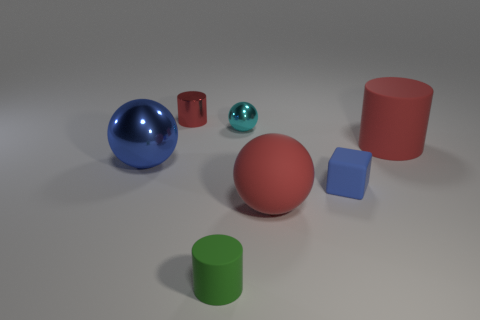Are there any metallic spheres of the same color as the rubber block?
Your answer should be very brief. Yes. What number of large objects are yellow metal spheres or green objects?
Give a very brief answer. 0. How many big blue shiny cylinders are there?
Your response must be concise. 0. What material is the small object that is in front of the tiny blue thing?
Your answer should be compact. Rubber. Are there any green rubber cylinders to the right of the big red rubber cylinder?
Your answer should be very brief. No. Is the red rubber cylinder the same size as the blue matte cube?
Provide a short and direct response. No. How many small cyan objects are the same material as the small green cylinder?
Make the answer very short. 0. There is a red cylinder that is to the left of the big red object in front of the big blue metal ball; what is its size?
Keep it short and to the point. Small. What is the color of the small thing that is both in front of the big shiny sphere and left of the small cyan sphere?
Make the answer very short. Green. Is the tiny red metallic thing the same shape as the blue matte thing?
Make the answer very short. No. 